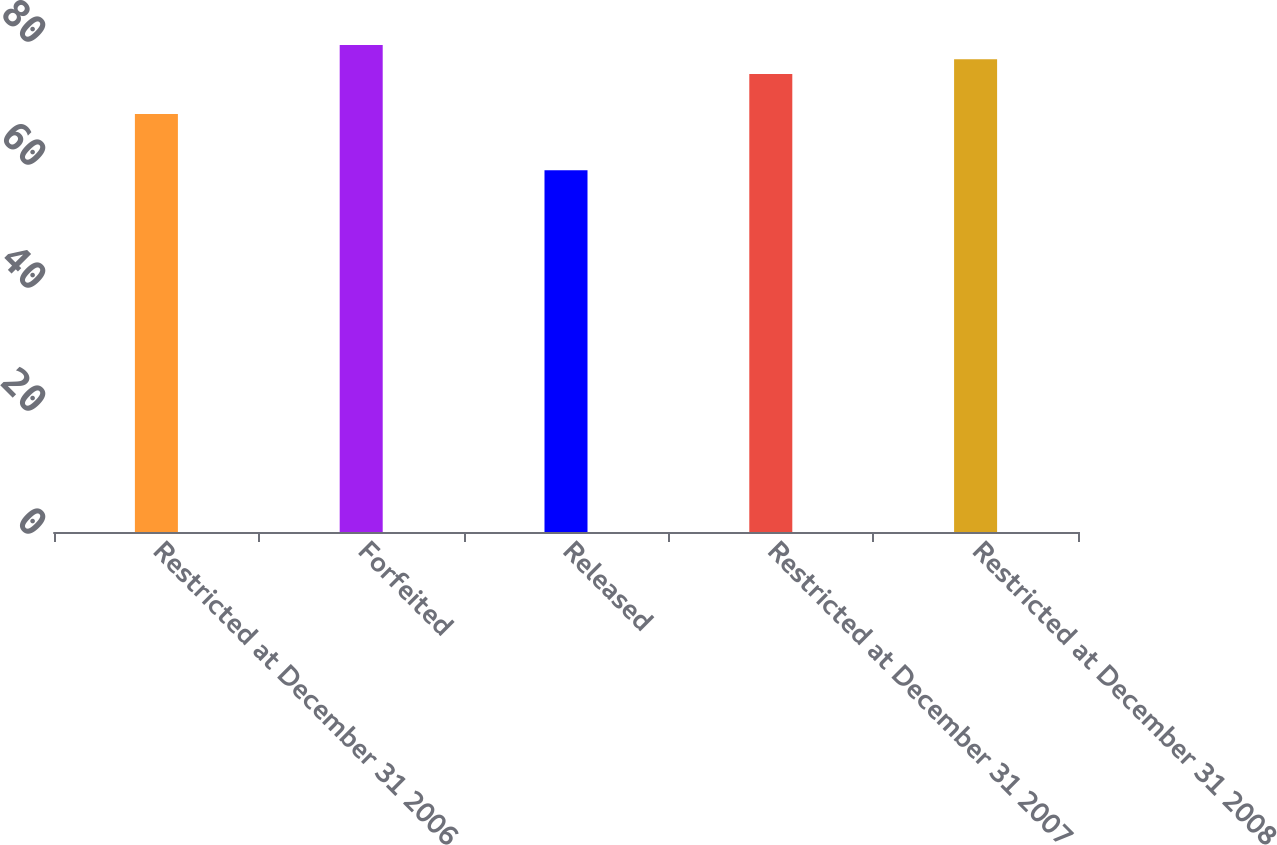Convert chart. <chart><loc_0><loc_0><loc_500><loc_500><bar_chart><fcel>Restricted at December 31 2006<fcel>Forfeited<fcel>Released<fcel>Restricted at December 31 2007<fcel>Restricted at December 31 2008<nl><fcel>67.96<fcel>79.19<fcel>58.84<fcel>74.47<fcel>76.87<nl></chart> 